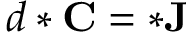Convert formula to latex. <formula><loc_0><loc_0><loc_500><loc_500>d * C = * J</formula> 